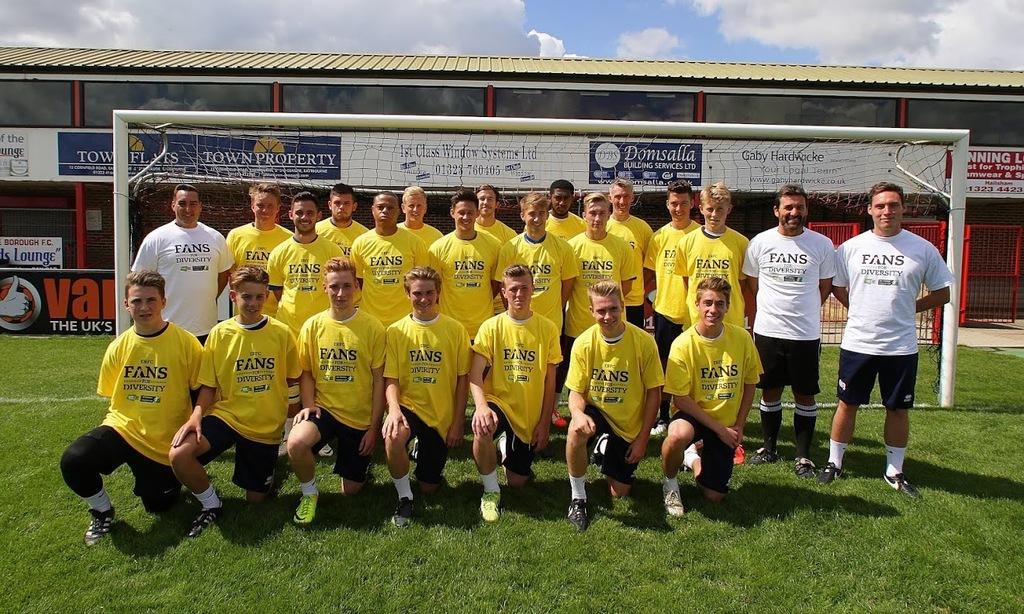In one or two sentences, can you explain what this image depicts? In this image we can see players on the ground. In the background we can see net, fencing and building. At the top of the image there are clouds and sky. 